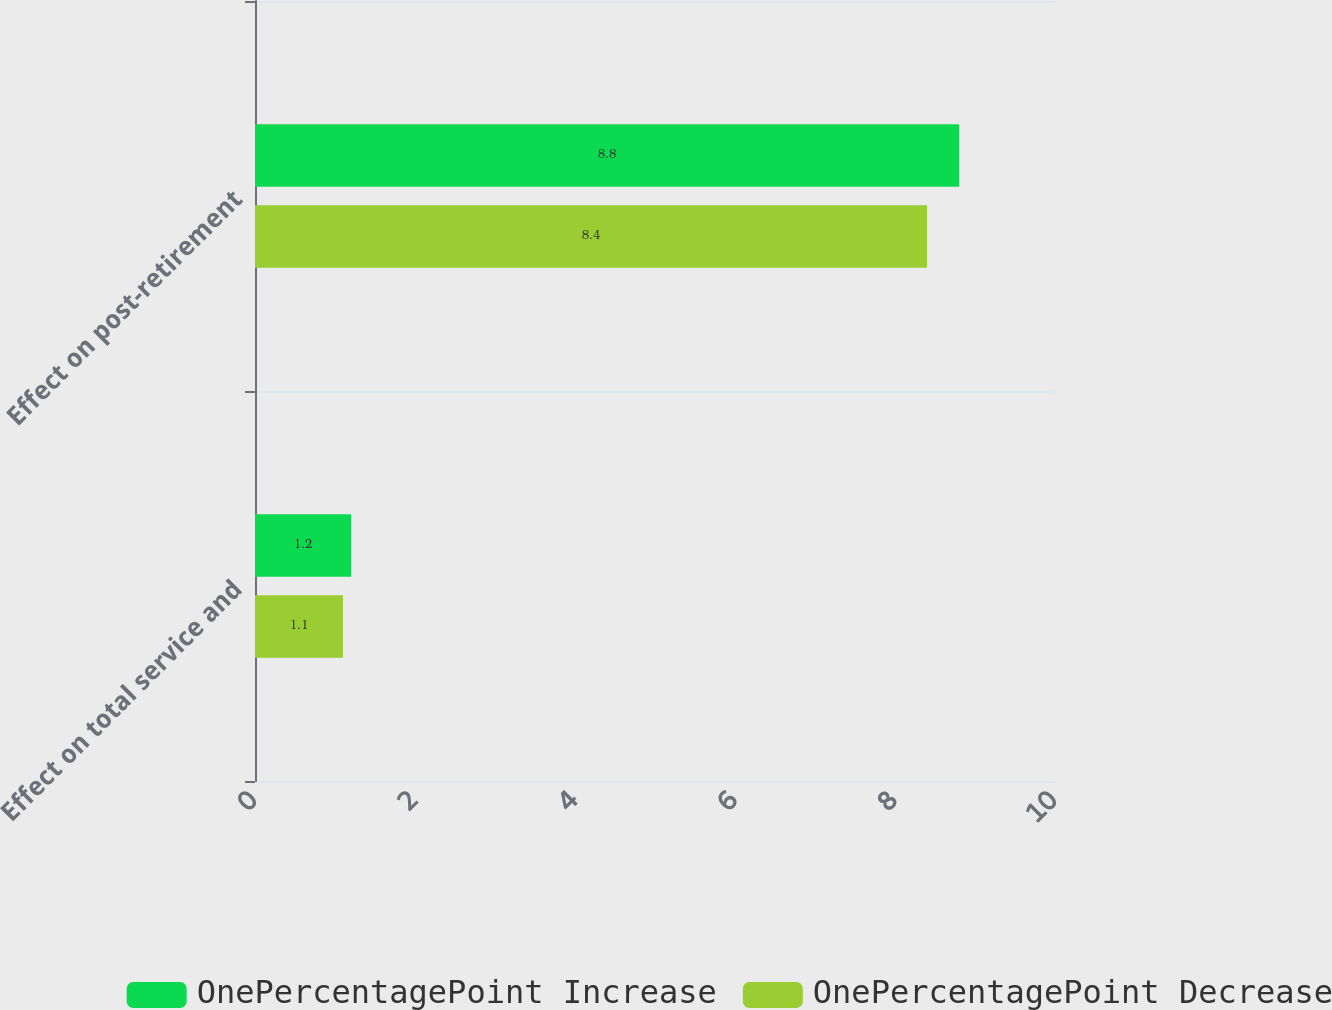Convert chart. <chart><loc_0><loc_0><loc_500><loc_500><stacked_bar_chart><ecel><fcel>Effect on total service and<fcel>Effect on post-retirement<nl><fcel>OnePercentagePoint Increase<fcel>1.2<fcel>8.8<nl><fcel>OnePercentagePoint Decrease<fcel>1.1<fcel>8.4<nl></chart> 